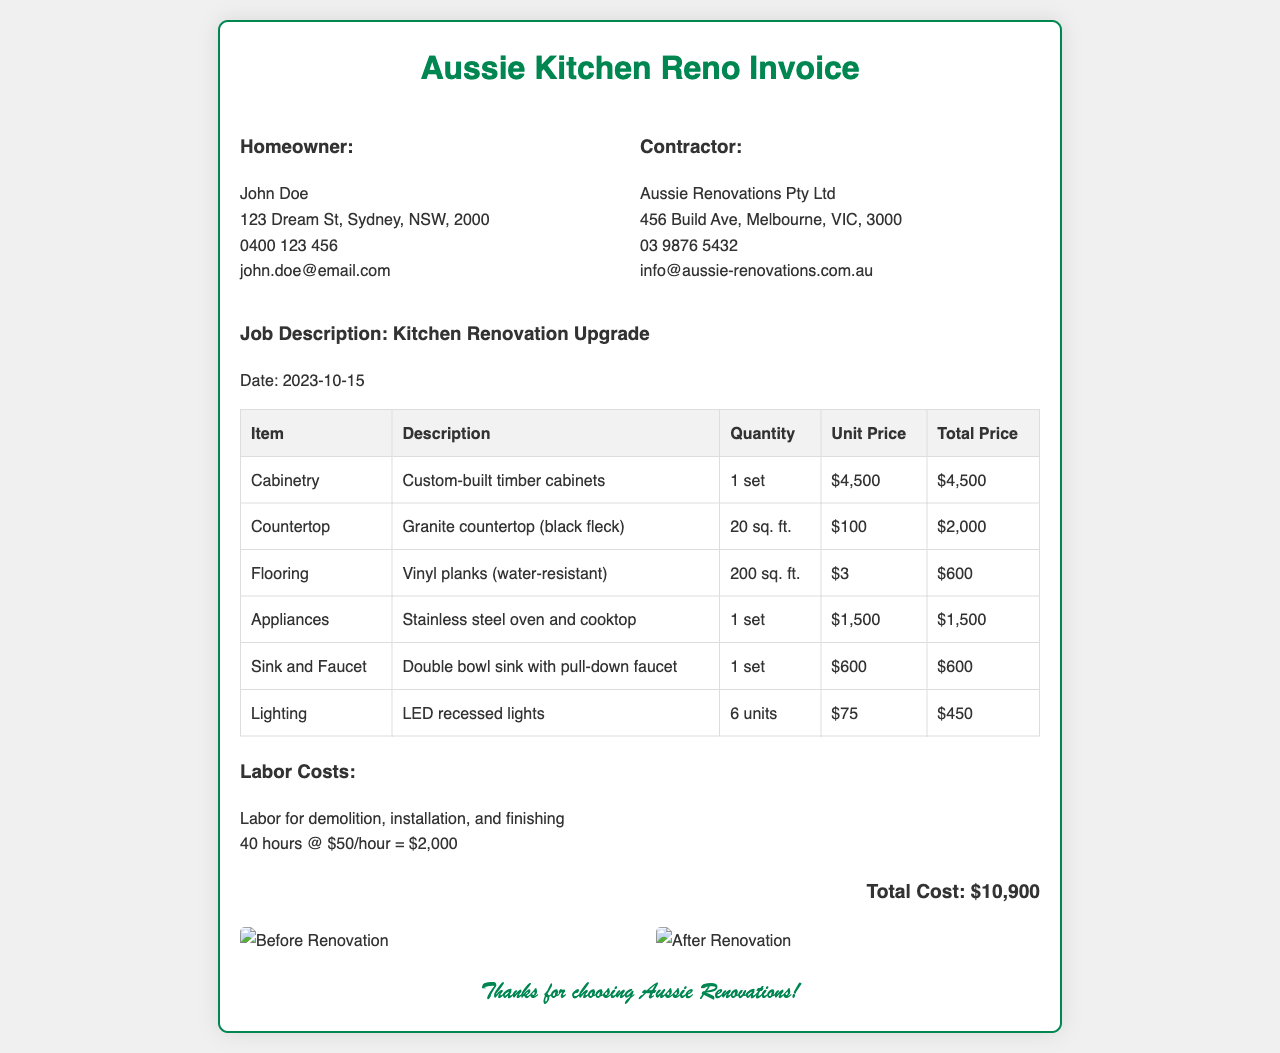What is the name of the homeowner? The homeowner's name is listed as John Doe in the document.
Answer: John Doe What is the total cost of the renovation? The total cost is summarized at the bottom of the invoice, showing the total amount due.
Answer: $10,900 How many hours of labor were charged? The invoice details that labor was billed for a total of 40 hours.
Answer: 40 hours What type of flooring was used? The flooring section specifies that vinyl planks were used for the renovation.
Answer: Vinyl planks What is the unit price for the granite countertop? The unit price for the granite countertop is provided in the table of materials.
Answer: $100 What is the quantity of cabinet sets installed? The invoice indicates that 1 set of cabinetry was installed.
Answer: 1 set Who is the contractor for the renovation? The contractor's name and details are provided, identifying who performed the services.
Answer: Aussie Renovations Pty Ltd What is the description of the sink installed? The invoice describes the sink that was installed as a double bowl sink.
Answer: Double bowl sink What type of lighting was installed? The lighting section mentions that LED recessed lights were part of the renovation.
Answer: LED recessed lights 